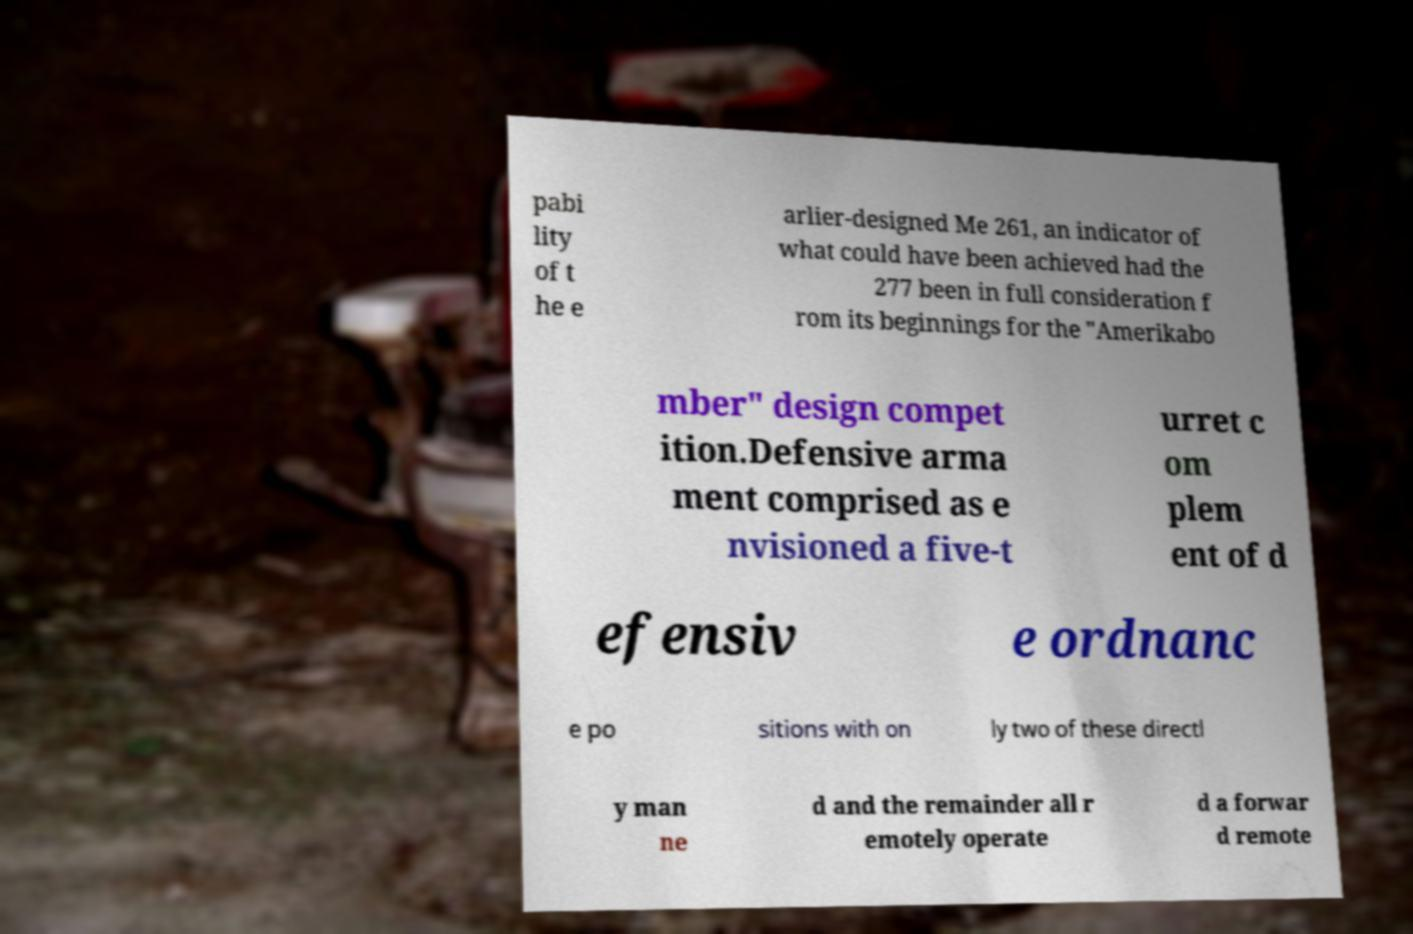Can you read and provide the text displayed in the image?This photo seems to have some interesting text. Can you extract and type it out for me? pabi lity of t he e arlier-designed Me 261, an indicator of what could have been achieved had the 277 been in full consideration f rom its beginnings for the "Amerikabo mber" design compet ition.Defensive arma ment comprised as e nvisioned a five-t urret c om plem ent of d efensiv e ordnanc e po sitions with on ly two of these directl y man ne d and the remainder all r emotely operate d a forwar d remote 